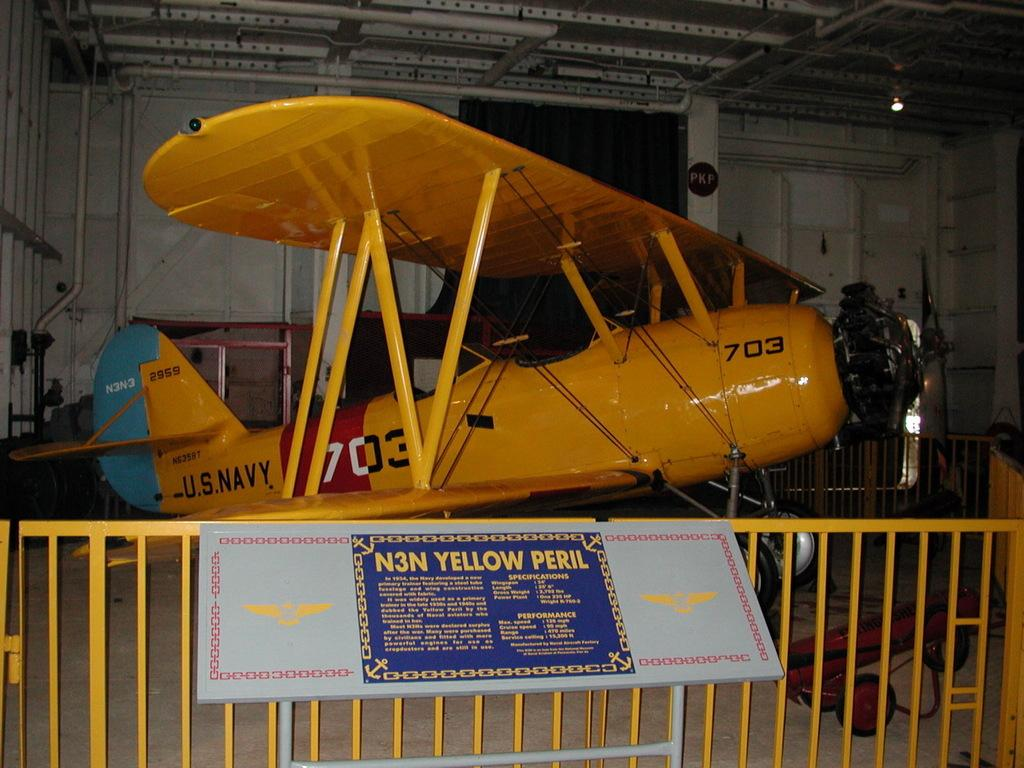<image>
Relay a brief, clear account of the picture shown. A yellow airplane with the number 703 on the side 